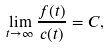<formula> <loc_0><loc_0><loc_500><loc_500>\lim _ { t \to \infty } \frac { f ( t ) } { c ( t ) } = C ,</formula> 